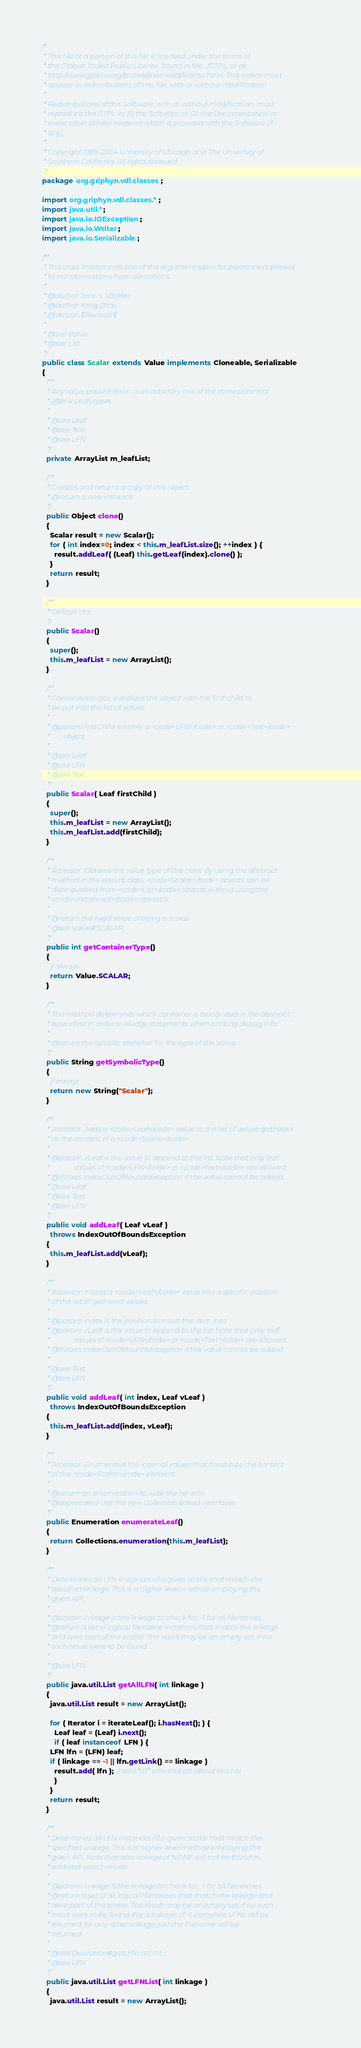<code> <loc_0><loc_0><loc_500><loc_500><_Java_>/*
 * This file or a portion of this file is licensed under the terms of
 * the Globus Toolkit Public License, found in file ../GTPL, or at
 * http://www.globus.org/toolkit/download/license.html. This notice must
 * appear in redistributions of this file, with or without modification.
 *
 * Redistributions of this Software, with or without modification, must
 * reproduce the GTPL in: (1) the Software, or (2) the Documentation or
 * some other similar material which is provided with the Software (if
 * any).
 *
 * Copyright 1999-2004 University of Chicago and The University of
 * Southern California. All rights reserved.
 */
package org.griphyn.vdl.classes;

import org.griphyn.vdl.classes.*;
import java.util.*;
import java.io.IOException;
import java.io.Writer;
import java.io.Serializable;

/**
 * This class implements one of the argument types for parameters passed
 * to transformations from derivations. 
 *
 * @author Jens-S. Vöckler
 * @author Yong Zhao
 * @version $Revision$
 *
 * @see Value
 * @see List
 */
public class Scalar extends Value implements Cloneable, Serializable
{
  /**
   * Any value passed down is an arbitrary mix of the three potential
   * {@link Leaf} types.
   *
   * @see Leaf
   * @see Text
   * @see LFN
   */
  private ArrayList m_leafList;

  /**
   * Creates and returns a copy of this object.
   * @return a new instance.
   */
  public Object clone()
  {
    Scalar result = new Scalar();
    for ( int index=0; index < this.m_leafList.size(); ++index ) {
      result.addLeaf( (Leaf) this.getLeaf(index).clone() );
    }
    return result;
  }

  /**
   * Default ctor.
   */
  public Scalar()
  {
    super();
    this.m_leafList = new ArrayList();
  }

  /**
   * Convenience ctor: Initializes the object with the first child to
   * be put into the list of values.
   *
   * @param firstChild is either a <code>LFN</code> or <code>Text</code>
   *        object.
   *
   * @see Leaf
   * @see LFN
   * @see Text
   */
  public Scalar( Leaf firstChild )
  {
    super();
    this.m_leafList = new ArrayList();
    this.m_leafList.add(firstChild);
  }

  /**
   * Accessor: Obtains the value type of this class. By using the abstract
   * method in the parent class, <code>Scalar</code> objects can be
   * distinguished from <code>List</code> objects without using the
   * <code>instanceof</code> operator.
   *
   * @return the fixed value of being a scalar. 
   * @see Value#SCALAR 
   */
  public int getContainerType()
  {
    // always
    return Value.SCALAR; 
  }

  /**
   * This method determines which container is being used in the abstract 
   * base class in order to kludgy statements when printing debug info.
   *
   * @return the symblic identifier for the type of the Value.
   */
  public String getSymbolicType()
  {
    // always
    return new String("Scalar");
  }

  /**
   * Accessor: Adds a <code>Leaf</code> value to the list of values gathered
   * as the content of a <code>Scalar</code>.
   *
   * @param vLeaf is the value to append to the list. Note that only leaf
   *              values of <code>LFN</code> or <code>Text</code> are allowed.
   * @throws IndexOutOfBoundsException if the value cannot be added.
   * @see Leaf
   * @see Text
   * @see LFN
   */
  public void addLeaf( Leaf vLeaf )
    throws IndexOutOfBoundsException
  { 
    this.m_leafList.add(vLeaf); 
  }
  
  /**
   * Accessor: Inserts a <code>Leaf</code> value into a specific position
   * of the list of gathered values.
   *
   * @param index is the position to insert the item into
   * @param vLeaf is the value to append to the list. Note that only leaf
   *              values of <code>LFN</code> or <code>Text</code> are allowed.
   * @throws IndexOutOfBoundsException if the value cannot be added.
   *
   * @see Text
   * @see LFN
   */
  public void addLeaf( int index, Leaf vLeaf )
    throws IndexOutOfBoundsException
  {
    this.m_leafList.add(index, vLeaf); 
  }

  /**
   * Accessor: Enumerates the internal values that constitute the content
   * of the <code>Scalar</code> element.
   *
   * @return an enumeration to walk the list with.
   * @deprecated Use the new Collection based interfaces
   */
  public Enumeration enumerateLeaf()
  { 
    return Collections.enumeration(this.m_leafList); 
  }

  /**
   * Determines all LFN instances of a given scalar that match the
   * specified linkage. This is a higher-level method employing the
   * given API.
   *
   * @param linkage is the linkage to check for, -1 for all filenames.
   * @return a set of logical filename instances that match the linkage
   * and were part of the scalar. The result may be an empty set, if no
   * such result were to be found.
   *
   * @see LFN 
   */
  public java.util.List getAllLFN( int linkage )
  {
    java.util.List result = new ArrayList();

    for ( Iterator i = iterateLeaf(); i.hasNext(); ) {
      Leaf leaf = (Leaf) i.next();
      if ( leaf instanceof LFN ) {
	LFN lfn = (LFN) leaf;
	if ( linkage == -1 || lfn.getLink() == linkage ) 
	  result.add( lfn ); // add *all* information about this file
      }
    }
    return result;
  }

  /**
   * Determines all LFN instances of a given scalar that match the
   * specified linkage. This is a higher-level method employing the
   * given API. Note that also linkage of NONE will not be found in
   * wildcard search mode.
   *
   * @param linkage is the linkage to check for, -1 for all filenames.
   * @return a set of all logical filenames that match the linkage and
   * were part of the scalar. The result may be an empty set, if no such
   * result were to be found. For a linkage of -1, complete LFNs will be
   * returned, for any other linkage, just the filename will be
   * returned.
   *
   * @see Derivation#getLFNList( int ) 
   * @see LFN 
   */
  public java.util.List getLFNList( int linkage )
  {
    java.util.List result = new ArrayList();
</code> 